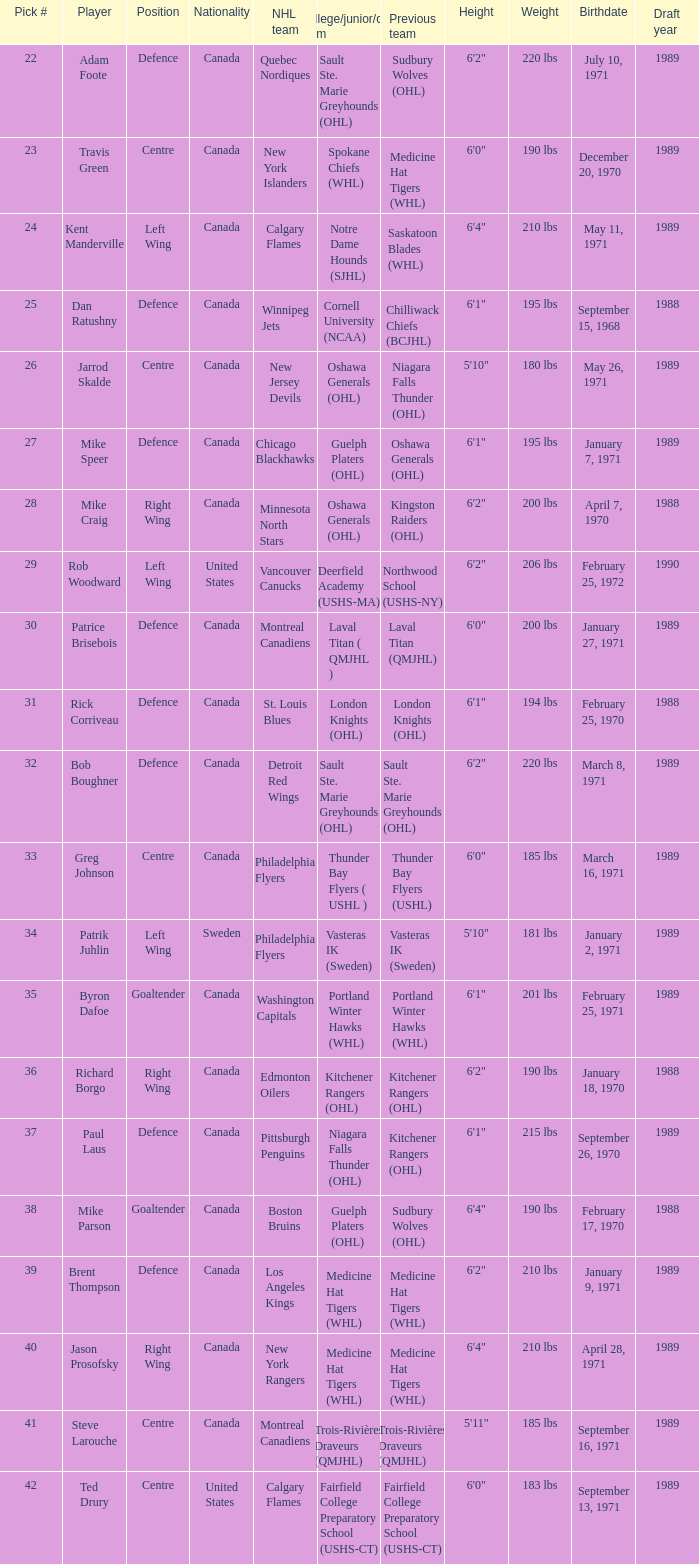What player came from Cornell University (NCAA)? Dan Ratushny. 